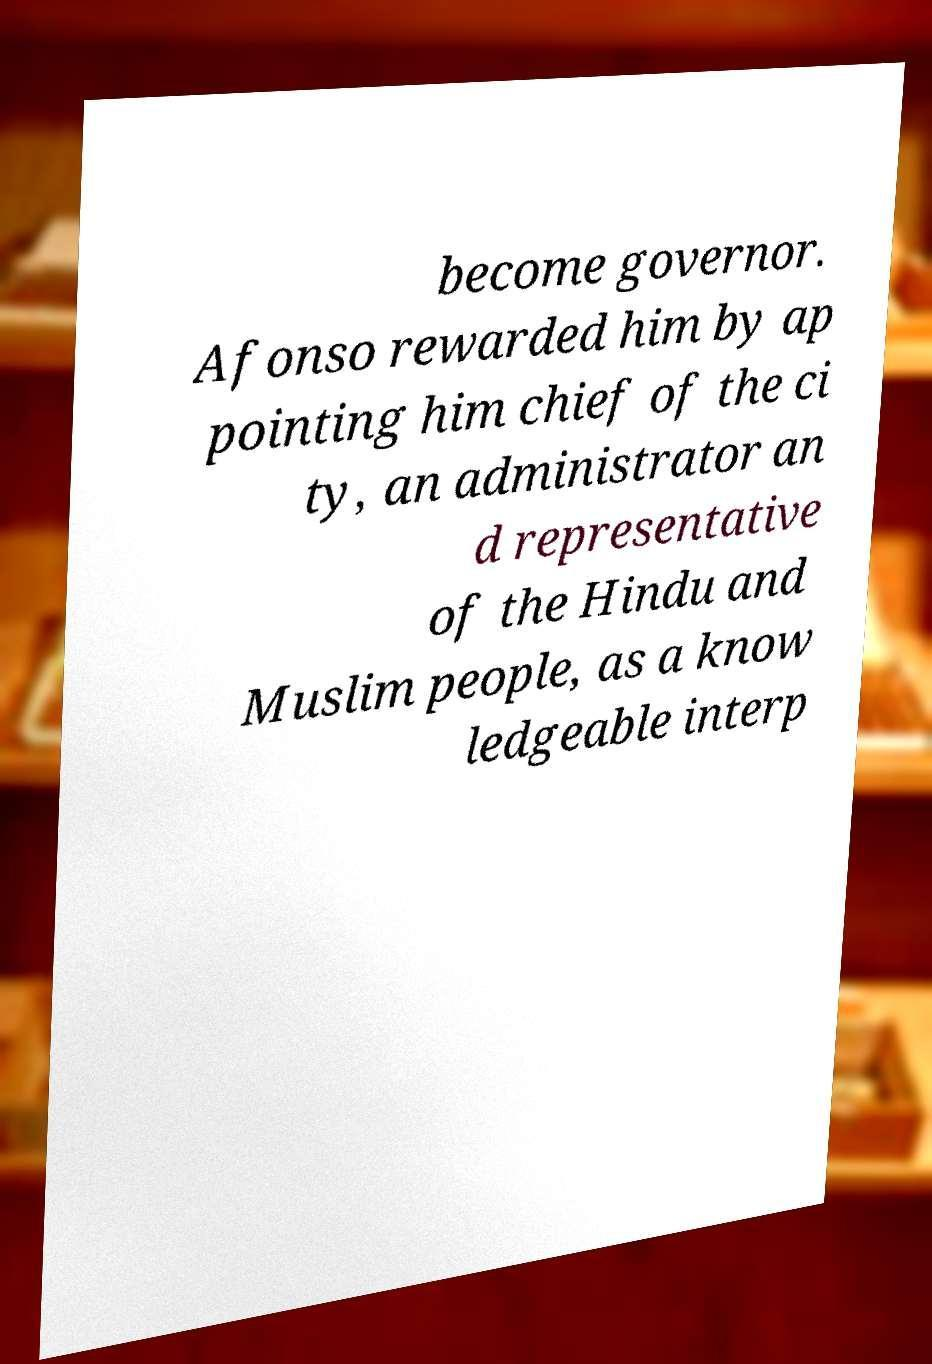For documentation purposes, I need the text within this image transcribed. Could you provide that? become governor. Afonso rewarded him by ap pointing him chief of the ci ty, an administrator an d representative of the Hindu and Muslim people, as a know ledgeable interp 